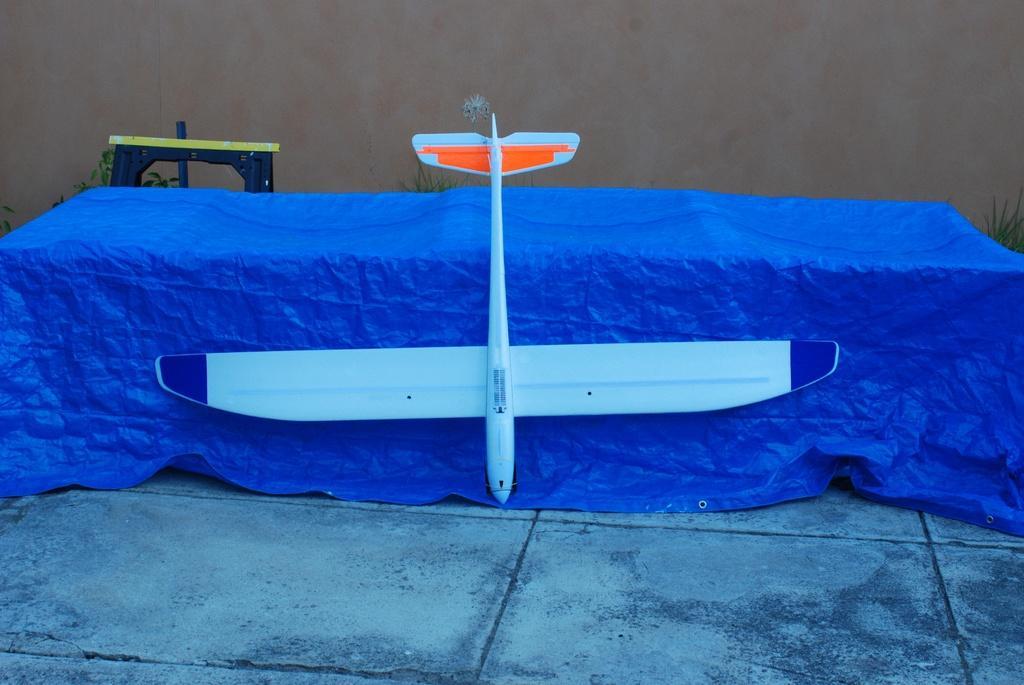Describe this image in one or two sentences. In the picture we can see a table on it, we can see a blue colored cloth and on it we can see an aircraft placed in it and behind the table, we can see a stool and some plants near it and in the background we can see a wall. 